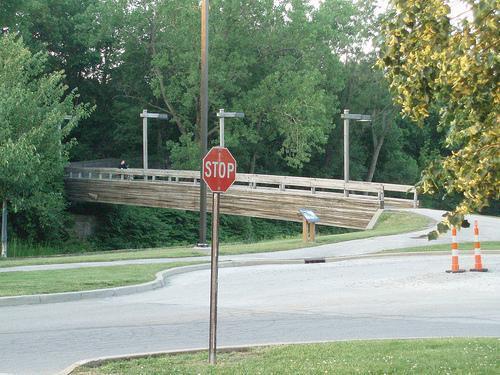How many cones are there?
Give a very brief answer. 2. How many bridges in the picture?
Give a very brief answer. 1. How many grates are on the street?
Give a very brief answer. 1. 